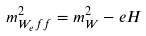Convert formula to latex. <formula><loc_0><loc_0><loc_500><loc_500>m _ { W _ { e } f f } ^ { 2 } = m _ { W } ^ { 2 } - e H</formula> 